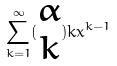Convert formula to latex. <formula><loc_0><loc_0><loc_500><loc_500>\sum _ { k = 1 } ^ { \infty } ( \begin{matrix} \alpha \\ k \end{matrix} ) k x ^ { k - 1 }</formula> 